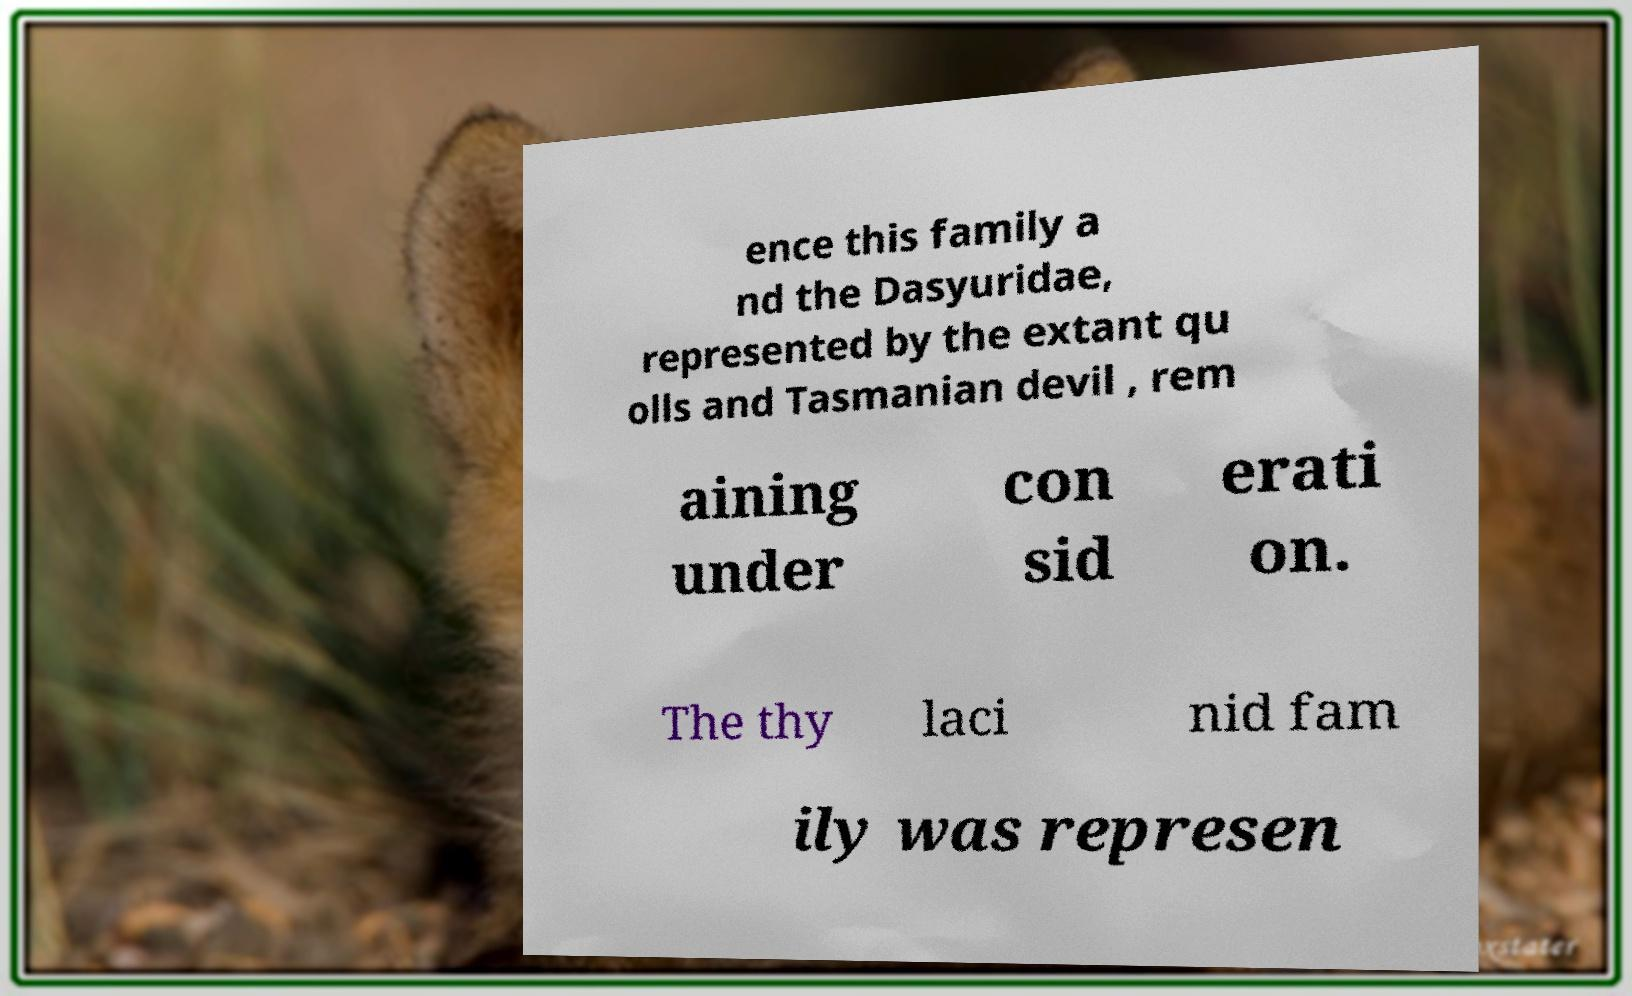There's text embedded in this image that I need extracted. Can you transcribe it verbatim? ence this family a nd the Dasyuridae, represented by the extant qu olls and Tasmanian devil , rem aining under con sid erati on. The thy laci nid fam ily was represen 